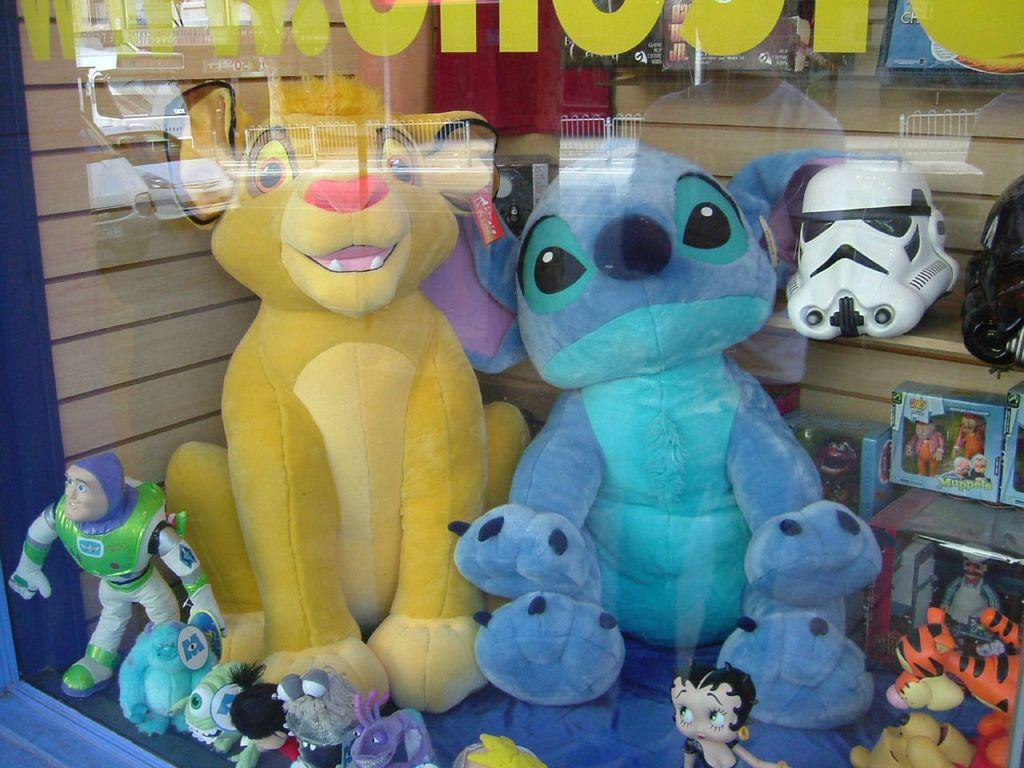What type of store is shown in the image? There is a toy store in the image. What can be seen inside the toy store? There are colorful toys in the image. How are the toys arranged in the toy store? There are toys on a rack in the image. Is there any barrier or protection for the toys in the image? Yes, there is a glass in front of the toys in the image. What type of plantation can be seen in the image? There is no plantation present in the image; it features a toy store with colorful toys. How does the mind of the toy store owner influence the arrangement of the toys in the image? The image does not provide any information about the toy store owner's mind or thoughts, so we cannot determine how it might influence the arrangement of the toys. 